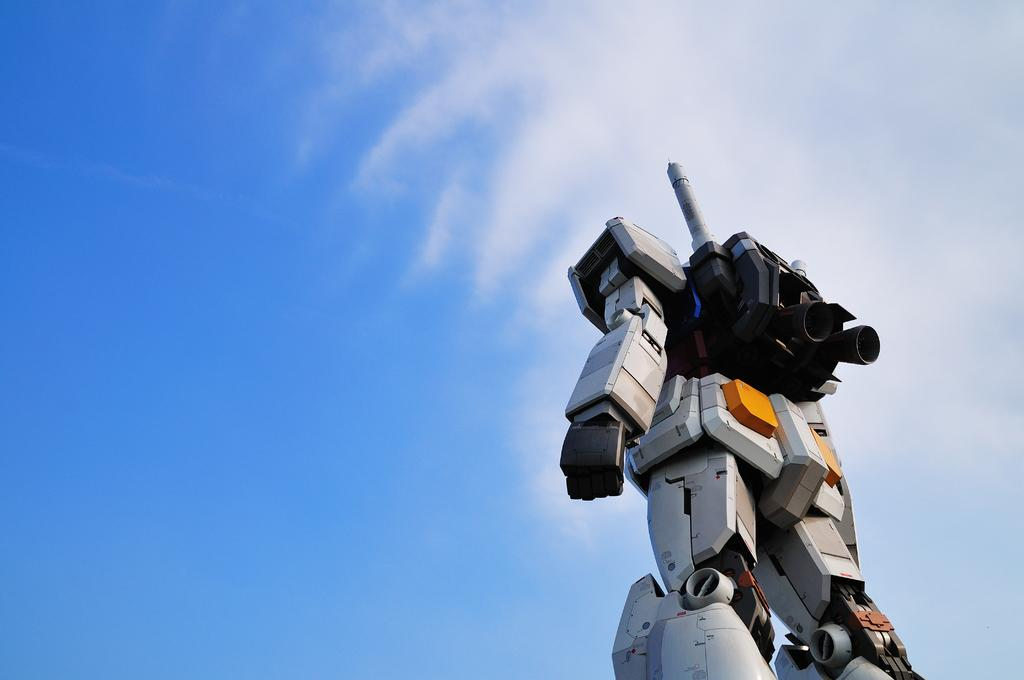What is the main subject of the image? There is a robot in the image. Where is the robot located in the image? The robot is located towards the bottom of the image. What can be seen in the background of the image? There is sky visible in the image, and there are clouds in the sky. What type of feather can be seen falling from the sky in the image? There is no feather present in the image; it only features a robot and clouds in the sky. 